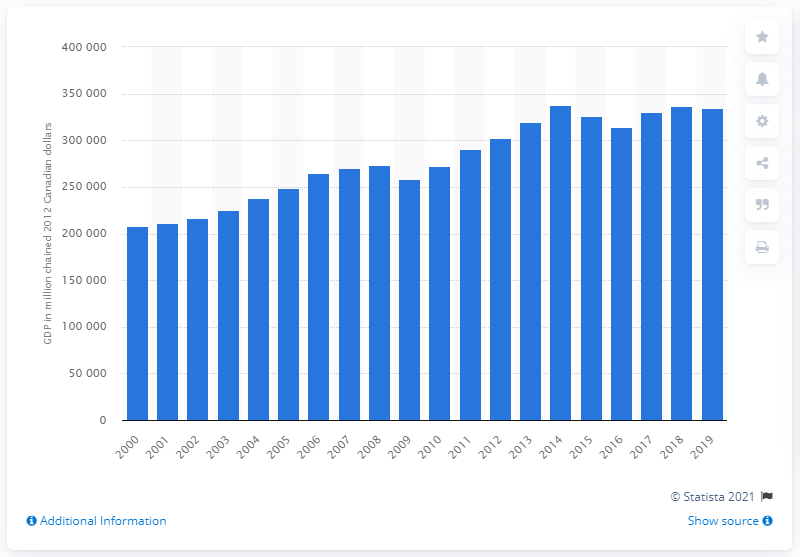Give some essential details in this illustration. In 2019, Alberta's Gross Domestic Product (GDP) was 334,172.2. 